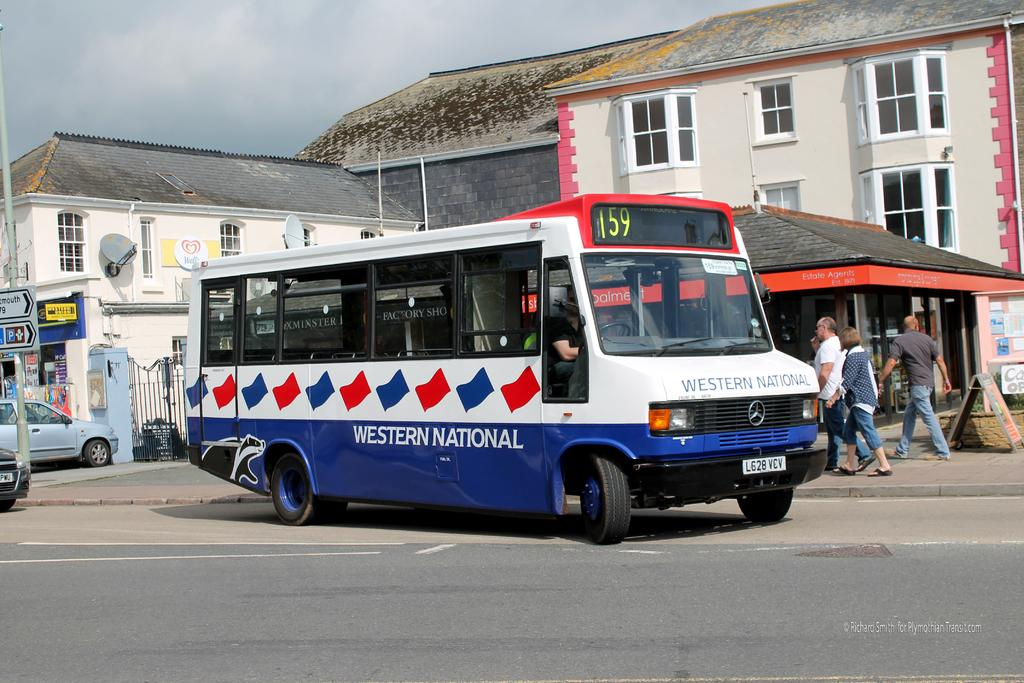<image>
Give a short and clear explanation of the subsequent image. Bust number 159 with Western National on he side. 